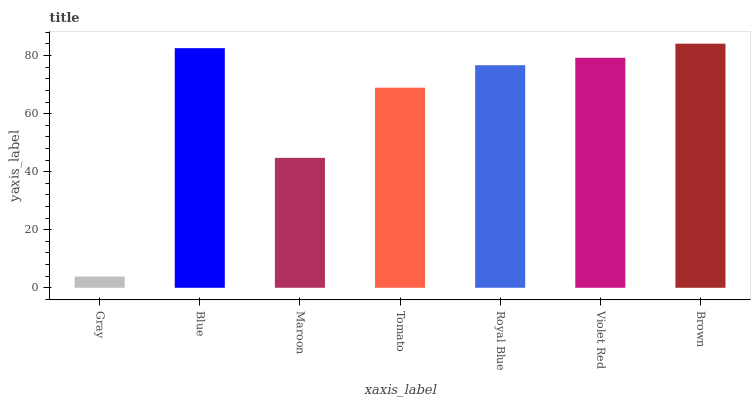Is Gray the minimum?
Answer yes or no. Yes. Is Brown the maximum?
Answer yes or no. Yes. Is Blue the minimum?
Answer yes or no. No. Is Blue the maximum?
Answer yes or no. No. Is Blue greater than Gray?
Answer yes or no. Yes. Is Gray less than Blue?
Answer yes or no. Yes. Is Gray greater than Blue?
Answer yes or no. No. Is Blue less than Gray?
Answer yes or no. No. Is Royal Blue the high median?
Answer yes or no. Yes. Is Royal Blue the low median?
Answer yes or no. Yes. Is Gray the high median?
Answer yes or no. No. Is Maroon the low median?
Answer yes or no. No. 